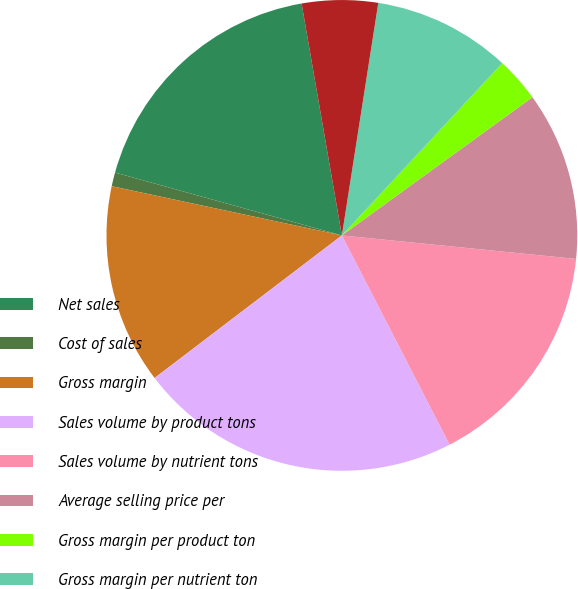Convert chart. <chart><loc_0><loc_0><loc_500><loc_500><pie_chart><fcel>Net sales<fcel>Cost of sales<fcel>Gross margin<fcel>Sales volume by product tons<fcel>Sales volume by nutrient tons<fcel>Average selling price per<fcel>Gross margin per product ton<fcel>Gross margin per nutrient ton<fcel>Depreciation and amortization<nl><fcel>17.96%<fcel>0.95%<fcel>13.71%<fcel>22.21%<fcel>15.84%<fcel>11.58%<fcel>3.08%<fcel>9.46%<fcel>5.21%<nl></chart> 